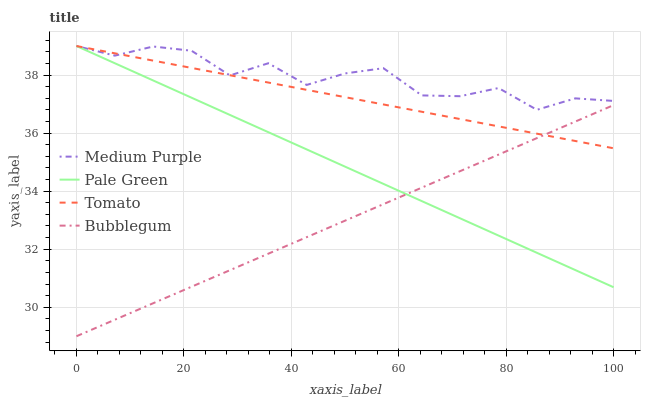Does Bubblegum have the minimum area under the curve?
Answer yes or no. Yes. Does Medium Purple have the maximum area under the curve?
Answer yes or no. Yes. Does Tomato have the minimum area under the curve?
Answer yes or no. No. Does Tomato have the maximum area under the curve?
Answer yes or no. No. Is Tomato the smoothest?
Answer yes or no. Yes. Is Medium Purple the roughest?
Answer yes or no. Yes. Is Pale Green the smoothest?
Answer yes or no. No. Is Pale Green the roughest?
Answer yes or no. No. Does Bubblegum have the lowest value?
Answer yes or no. Yes. Does Tomato have the lowest value?
Answer yes or no. No. Does Pale Green have the highest value?
Answer yes or no. Yes. Does Bubblegum have the highest value?
Answer yes or no. No. Is Bubblegum less than Medium Purple?
Answer yes or no. Yes. Is Medium Purple greater than Bubblegum?
Answer yes or no. Yes. Does Pale Green intersect Medium Purple?
Answer yes or no. Yes. Is Pale Green less than Medium Purple?
Answer yes or no. No. Is Pale Green greater than Medium Purple?
Answer yes or no. No. Does Bubblegum intersect Medium Purple?
Answer yes or no. No. 